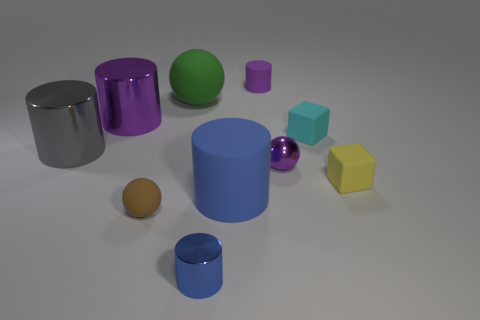Are there any other things that have the same material as the small blue cylinder?
Your response must be concise. Yes. What shape is the metallic object that is the same color as the tiny shiny sphere?
Keep it short and to the point. Cylinder. What size is the matte block that is behind the small purple metallic object right of the shiny cylinder behind the big gray cylinder?
Your answer should be very brief. Small. What is the material of the purple sphere?
Your answer should be compact. Metal. Does the tiny blue object have the same material as the small sphere behind the yellow matte cube?
Keep it short and to the point. Yes. Are there any other things of the same color as the small matte ball?
Provide a succinct answer. No. There is a large matte thing in front of the tiny block that is on the left side of the small yellow object; are there any small blocks that are in front of it?
Your response must be concise. No. The small rubber sphere is what color?
Offer a very short reply. Brown. Are there any blue cylinders behind the yellow matte object?
Provide a succinct answer. No. There is a big gray metal thing; does it have the same shape as the large matte thing left of the large blue rubber thing?
Ensure brevity in your answer.  No. 